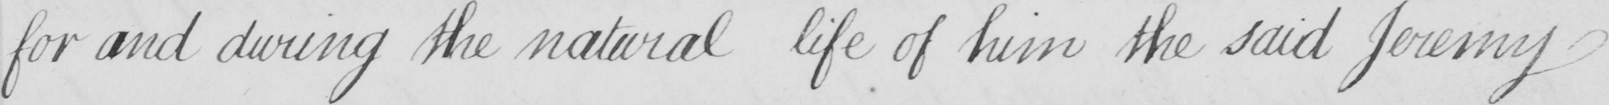Can you read and transcribe this handwriting? for and during the natural life of him the said Jeremy 